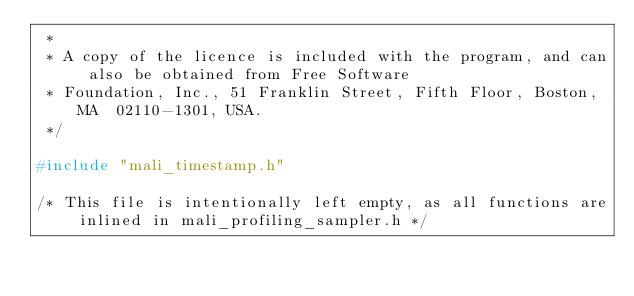<code> <loc_0><loc_0><loc_500><loc_500><_C_> * 
 * A copy of the licence is included with the program, and can also be obtained from Free Software
 * Foundation, Inc., 51 Franklin Street, Fifth Floor, Boston, MA  02110-1301, USA.
 */

#include "mali_timestamp.h"

/* This file is intentionally left empty, as all functions are inlined in mali_profiling_sampler.h */
</code> 